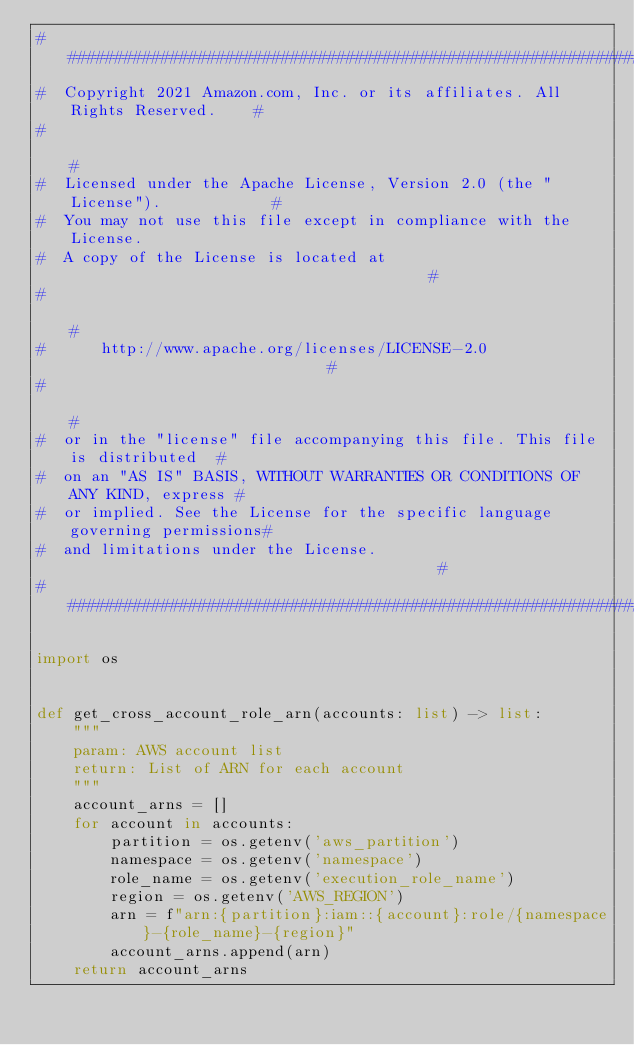<code> <loc_0><loc_0><loc_500><loc_500><_Python_>###############################################################################
#  Copyright 2021 Amazon.com, Inc. or its affiliates. All Rights Reserved.    #
#                                                                             #
#  Licensed under the Apache License, Version 2.0 (the "License").            #
#  You may not use this file except in compliance with the License.
#  A copy of the License is located at                                        #
#                                                                             #
#      http://www.apache.org/licenses/LICENSE-2.0                             #
#                                                                             #
#  or in the "license" file accompanying this file. This file is distributed  #
#  on an "AS IS" BASIS, WITHOUT WARRANTIES OR CONDITIONS OF ANY KIND, express #
#  or implied. See the License for the specific language governing permissions#
#  and limitations under the License.                                         #
###############################################################################

import os


def get_cross_account_role_arn(accounts: list) -> list:
    """
    param: AWS account list
    return: List of ARN for each account
    """
    account_arns = []
    for account in accounts:
        partition = os.getenv('aws_partition')
        namespace = os.getenv('namespace')
        role_name = os.getenv('execution_role_name')
        region = os.getenv('AWS_REGION')
        arn = f"arn:{partition}:iam::{account}:role/{namespace}-{role_name}-{region}"
        account_arns.append(arn)
    return account_arns
</code> 